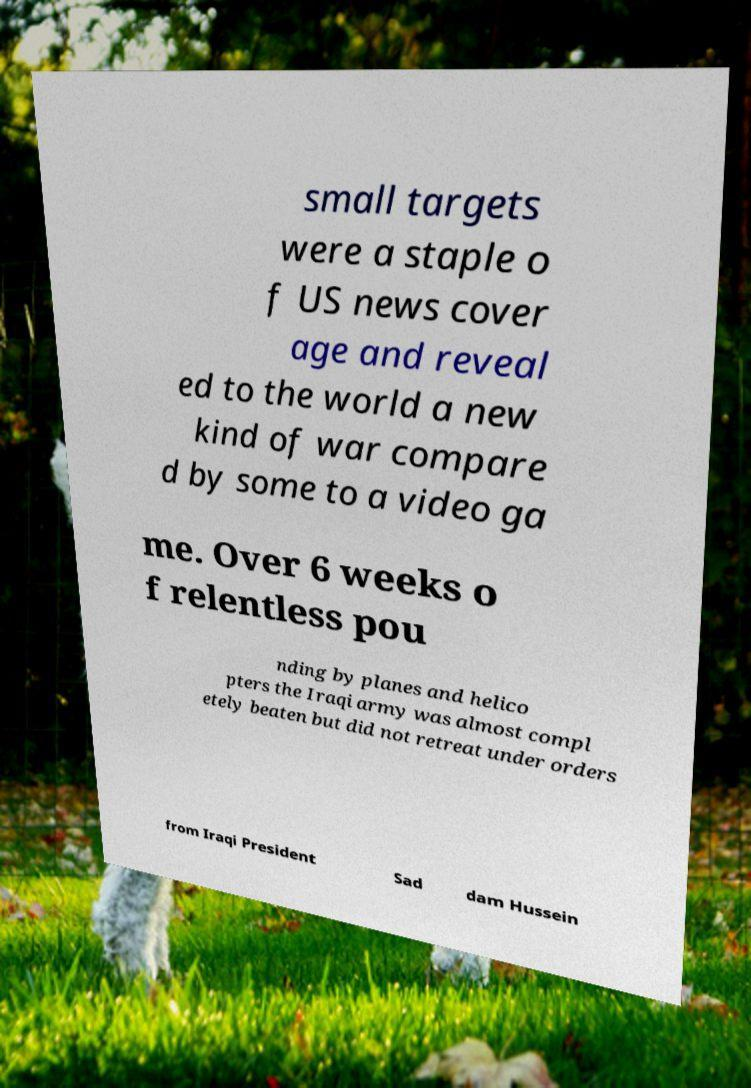Please identify and transcribe the text found in this image. small targets were a staple o f US news cover age and reveal ed to the world a new kind of war compare d by some to a video ga me. Over 6 weeks o f relentless pou nding by planes and helico pters the Iraqi army was almost compl etely beaten but did not retreat under orders from Iraqi President Sad dam Hussein 